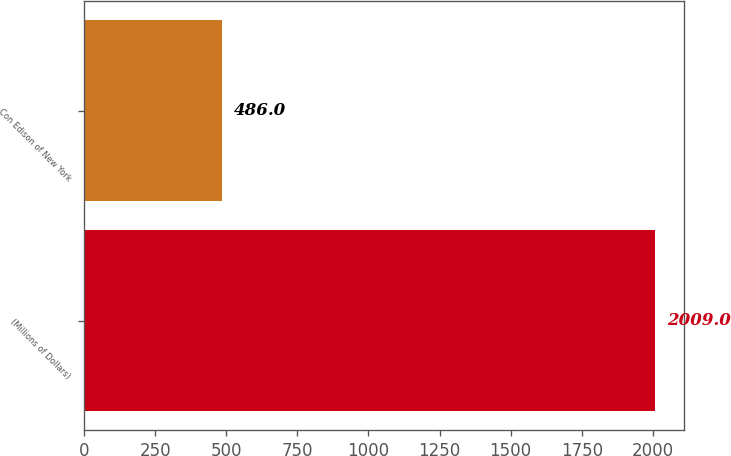Convert chart to OTSL. <chart><loc_0><loc_0><loc_500><loc_500><bar_chart><fcel>(Millions of Dollars)<fcel>Con Edison of New York<nl><fcel>2009<fcel>486<nl></chart> 